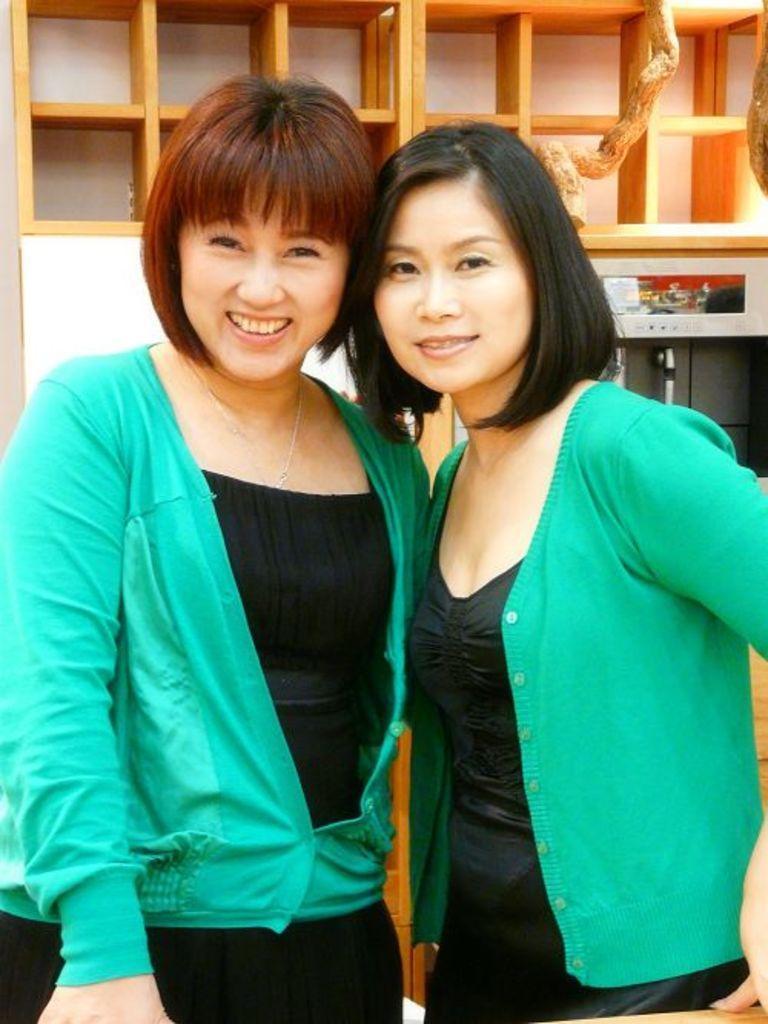In one or two sentences, can you explain what this image depicts? In this image there are two girls standing together wearing same costume, behind them there is a shelf. 